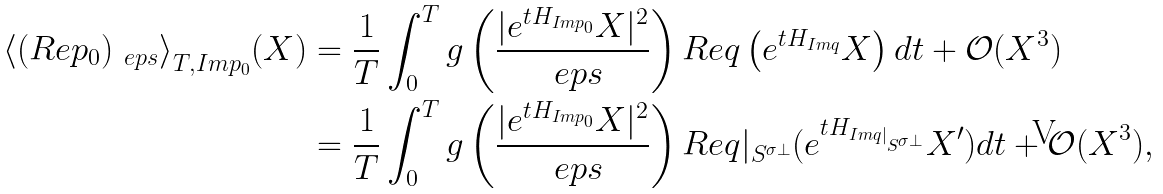Convert formula to latex. <formula><loc_0><loc_0><loc_500><loc_500>\langle { ( R e p _ { 0 } ) _ { \ e p s } \rangle } _ { T , I m p _ { 0 } } ( X ) = & \ \frac { 1 } { T } \int _ { 0 } ^ { T } g \left ( \frac { | e ^ { t H _ { I m p _ { 0 } } } X | ^ { 2 } } { \ e p s } \right ) R e q \left ( e ^ { t H _ { I m q } } X \right ) d t + \mathcal { O } ( X ^ { 3 } ) \\ = & \ \frac { 1 } { T } \int _ { 0 } ^ { T } g \left ( \frac { | e ^ { t H _ { I m p _ { 0 } } } X | ^ { 2 } } { \ e p s } \right ) R e q | _ { S ^ { \sigma \perp } } ( e ^ { t H _ { I m q | _ { S ^ { \sigma \perp } } } } X ^ { \prime } ) d t + \mathcal { O } ( X ^ { 3 } ) ,</formula> 